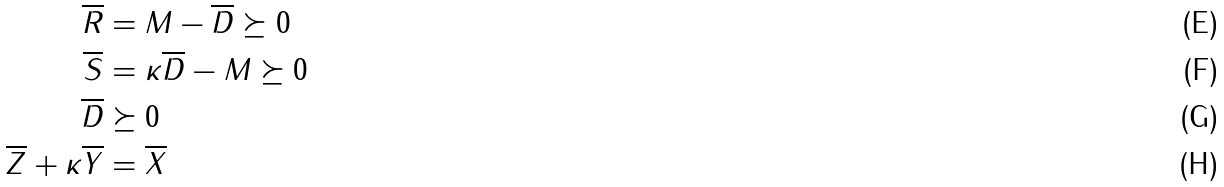Convert formula to latex. <formula><loc_0><loc_0><loc_500><loc_500>\overline { R } & = M - \overline { D } \succeq 0 \\ \overline { S } & = \kappa \overline { D } - M \succeq 0 \\ \overline { D } & \succeq 0 \\ \overline { Z } + \kappa \overline { Y } & = \overline { X }</formula> 